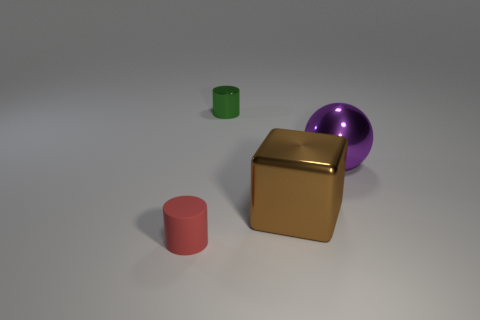Add 2 big balls. How many objects exist? 6 Subtract all blocks. How many objects are left? 3 Subtract 0 blue spheres. How many objects are left? 4 Subtract all big cubes. Subtract all large brown metal objects. How many objects are left? 2 Add 2 big brown metal cubes. How many big brown metal cubes are left? 3 Add 2 purple balls. How many purple balls exist? 3 